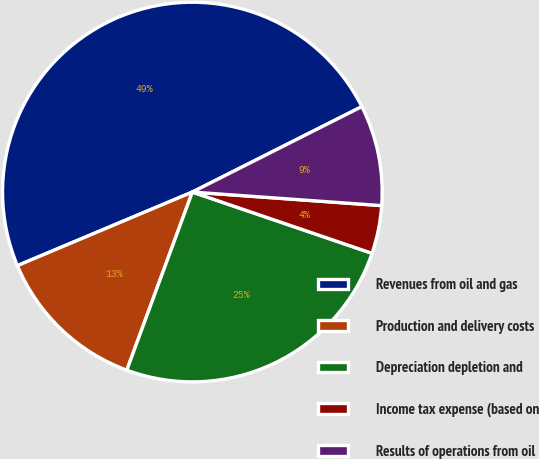<chart> <loc_0><loc_0><loc_500><loc_500><pie_chart><fcel>Revenues from oil and gas<fcel>Production and delivery costs<fcel>Depreciation depletion and<fcel>Income tax expense (based on<fcel>Results of operations from oil<nl><fcel>48.9%<fcel>13.05%<fcel>25.38%<fcel>4.09%<fcel>8.57%<nl></chart> 